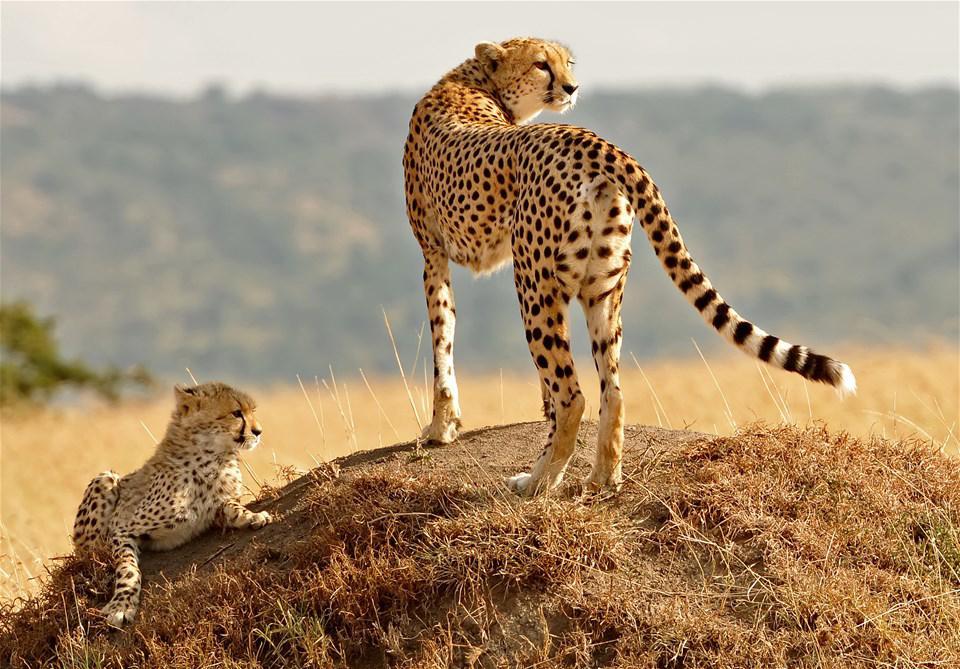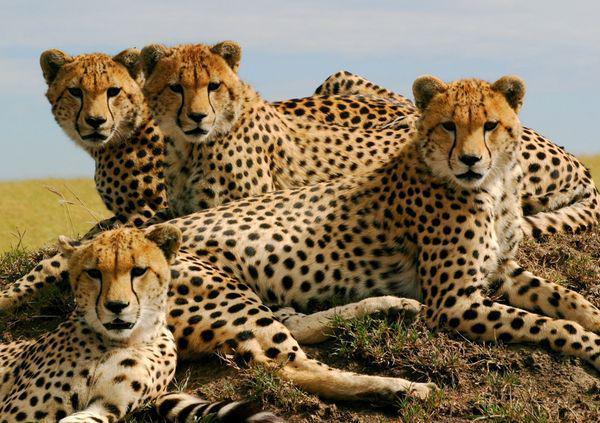The first image is the image on the left, the second image is the image on the right. For the images displayed, is the sentence "Right image shows three cheetahs looking in a variety of directions." factually correct? Answer yes or no. No. 